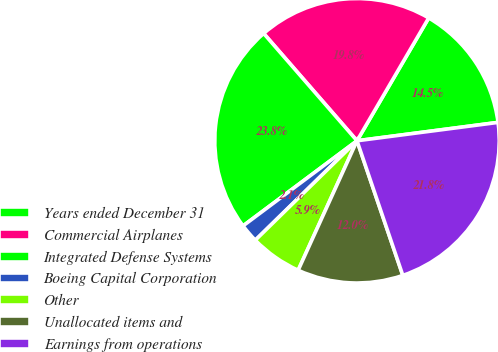<chart> <loc_0><loc_0><loc_500><loc_500><pie_chart><fcel>Years ended December 31<fcel>Commercial Airplanes<fcel>Integrated Defense Systems<fcel>Boeing Capital Corporation<fcel>Other<fcel>Unallocated items and<fcel>Earnings from operations<nl><fcel>14.53%<fcel>19.8%<fcel>23.82%<fcel>2.11%<fcel>5.89%<fcel>12.01%<fcel>21.84%<nl></chart> 